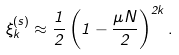<formula> <loc_0><loc_0><loc_500><loc_500>\xi ^ { ( s ) } _ { k } \approx \frac { 1 } { 2 } \left ( 1 - \frac { \mu N } { 2 } \right ) ^ { 2 k } .</formula> 